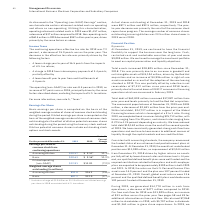According to International Business Machines's financial document, What caused the decrease in the actual shares? Based on the financial document, the answer is The year-to- year decrease was primarily the result of the common stock repurchase program. Also, What was the increase / (decrease) in the average number of common shares in 2019? 23.5 million shares lower in 2019 versus 2018. The document states: "f common shares outstanding assuming dilution was 23.5 million shares lower in 2019 versus 2018...." Also, What additional charges were included in 2018? Includes a charge of $2.0 billion or $2.23 of basic and diluted earnings per share in 2018 associated with U.S. tax reform.. The document states: "* Includes a charge of $2.0 billion or $2.23 of basic and diluted earnings per share in 2018 associated with U.S. tax reform...." Also, can you calculate: What was the increase / (decrease) from the Earnings per share of common stock from continuing operations basic? Based on the calculation: 10.63 - 9.56, the result is 1.07. This is based on the information: "Basic $10.63 $ 9.56* 11.2% Basic $10.63 $ 9.56* 11.2%..." The key data points involved are: 10.63, 9.56. Also, can you calculate: What is the increase / (decrease) from the Earnings per share of common stock from continuing operations Diluted operating (non-GAAP)? Based on the calculation: 12.81 - 13.81, the result is -1. This is based on the information: "Diluted operating (non-GAAP) $12.81 $13.81 (7.2)% Diluted operating (non-GAAP) $12.81 $13.81 (7.2)%..." The key data points involved are: 12.81, 13.81. Also, can you calculate: What is the increase / (decrease) in the Weighted-average shares outstanding assuming dilution? Based on the calculation: 892.8 - 916.3, the result is -23.5. This is based on the information: "Assuming dilution 892.8 916.3 (2.6)% Assuming dilution 892.8 916.3 (2.6)%..." The key data points involved are: 892.8, 916.3. 